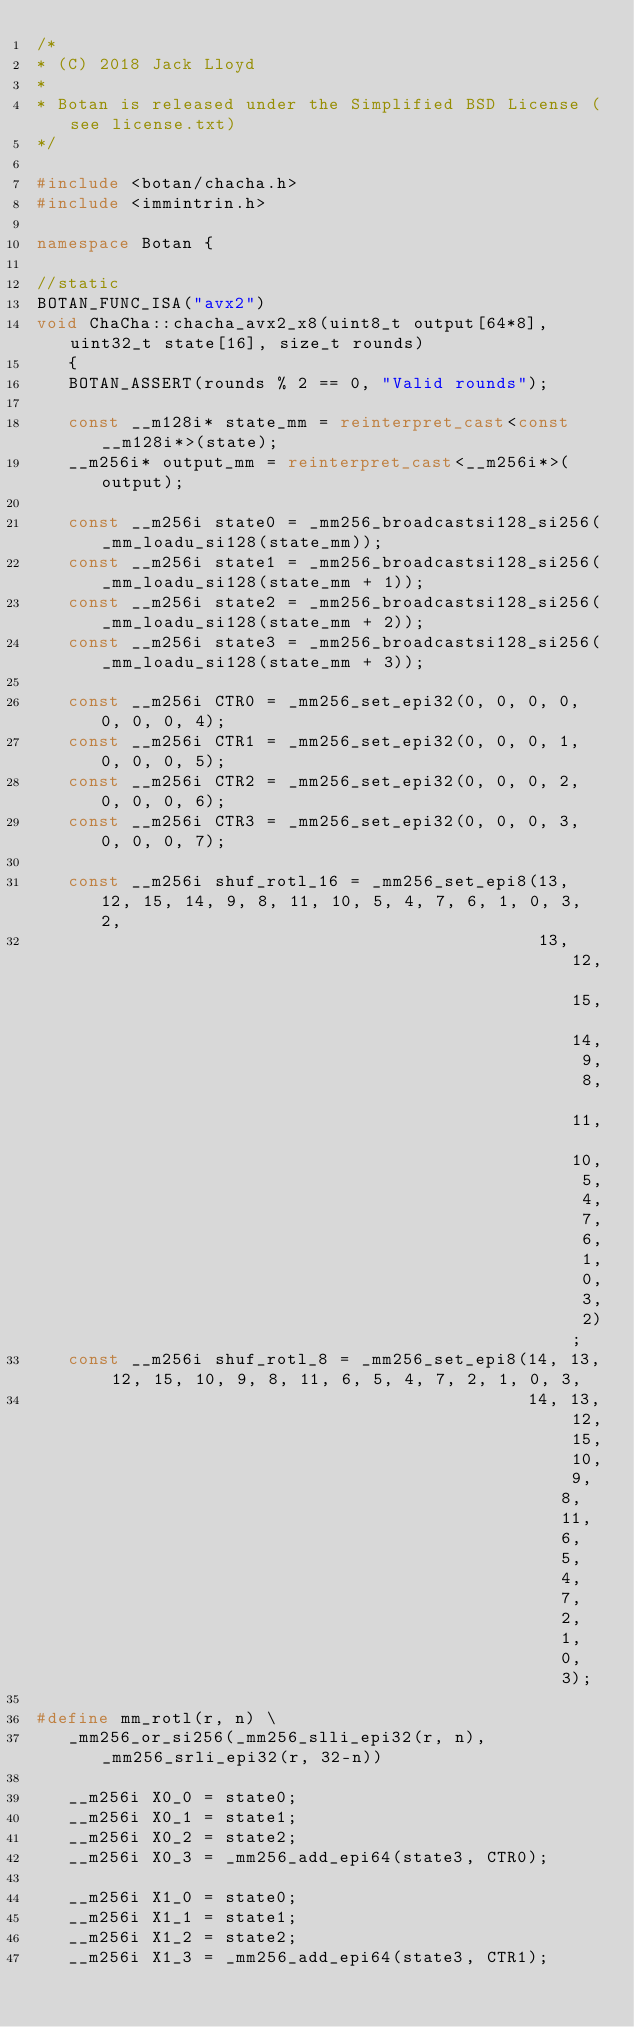<code> <loc_0><loc_0><loc_500><loc_500><_C++_>/*
* (C) 2018 Jack Lloyd
*
* Botan is released under the Simplified BSD License (see license.txt)
*/

#include <botan/chacha.h>
#include <immintrin.h>

namespace Botan {

//static
BOTAN_FUNC_ISA("avx2")
void ChaCha::chacha_avx2_x8(uint8_t output[64*8], uint32_t state[16], size_t rounds)
   {
   BOTAN_ASSERT(rounds % 2 == 0, "Valid rounds");

   const __m128i* state_mm = reinterpret_cast<const __m128i*>(state);
   __m256i* output_mm = reinterpret_cast<__m256i*>(output);

   const __m256i state0 = _mm256_broadcastsi128_si256(_mm_loadu_si128(state_mm));
   const __m256i state1 = _mm256_broadcastsi128_si256(_mm_loadu_si128(state_mm + 1));
   const __m256i state2 = _mm256_broadcastsi128_si256(_mm_loadu_si128(state_mm + 2));
   const __m256i state3 = _mm256_broadcastsi128_si256(_mm_loadu_si128(state_mm + 3));

   const __m256i CTR0 = _mm256_set_epi32(0, 0, 0, 0, 0, 0, 0, 4);
   const __m256i CTR1 = _mm256_set_epi32(0, 0, 0, 1, 0, 0, 0, 5);
   const __m256i CTR2 = _mm256_set_epi32(0, 0, 0, 2, 0, 0, 0, 6);
   const __m256i CTR3 = _mm256_set_epi32(0, 0, 0, 3, 0, 0, 0, 7);

   const __m256i shuf_rotl_16 = _mm256_set_epi8(13, 12, 15, 14, 9, 8, 11, 10, 5, 4, 7, 6, 1, 0, 3, 2,
                                                13, 12, 15, 14, 9, 8, 11, 10, 5, 4, 7, 6, 1, 0, 3, 2);
   const __m256i shuf_rotl_8 = _mm256_set_epi8(14, 13, 12, 15, 10, 9, 8, 11, 6, 5, 4, 7, 2, 1, 0, 3,
                                               14, 13, 12, 15, 10, 9, 8, 11, 6, 5, 4, 7, 2, 1, 0, 3);

#define mm_rotl(r, n) \
   _mm256_or_si256(_mm256_slli_epi32(r, n), _mm256_srli_epi32(r, 32-n))

   __m256i X0_0 = state0;
   __m256i X0_1 = state1;
   __m256i X0_2 = state2;
   __m256i X0_3 = _mm256_add_epi64(state3, CTR0);

   __m256i X1_0 = state0;
   __m256i X1_1 = state1;
   __m256i X1_2 = state2;
   __m256i X1_3 = _mm256_add_epi64(state3, CTR1);
</code> 